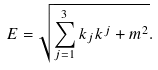Convert formula to latex. <formula><loc_0><loc_0><loc_500><loc_500>E = \sqrt { \sum _ { j = 1 } ^ { 3 } k _ { j } k ^ { j } + m ^ { 2 } } .</formula> 